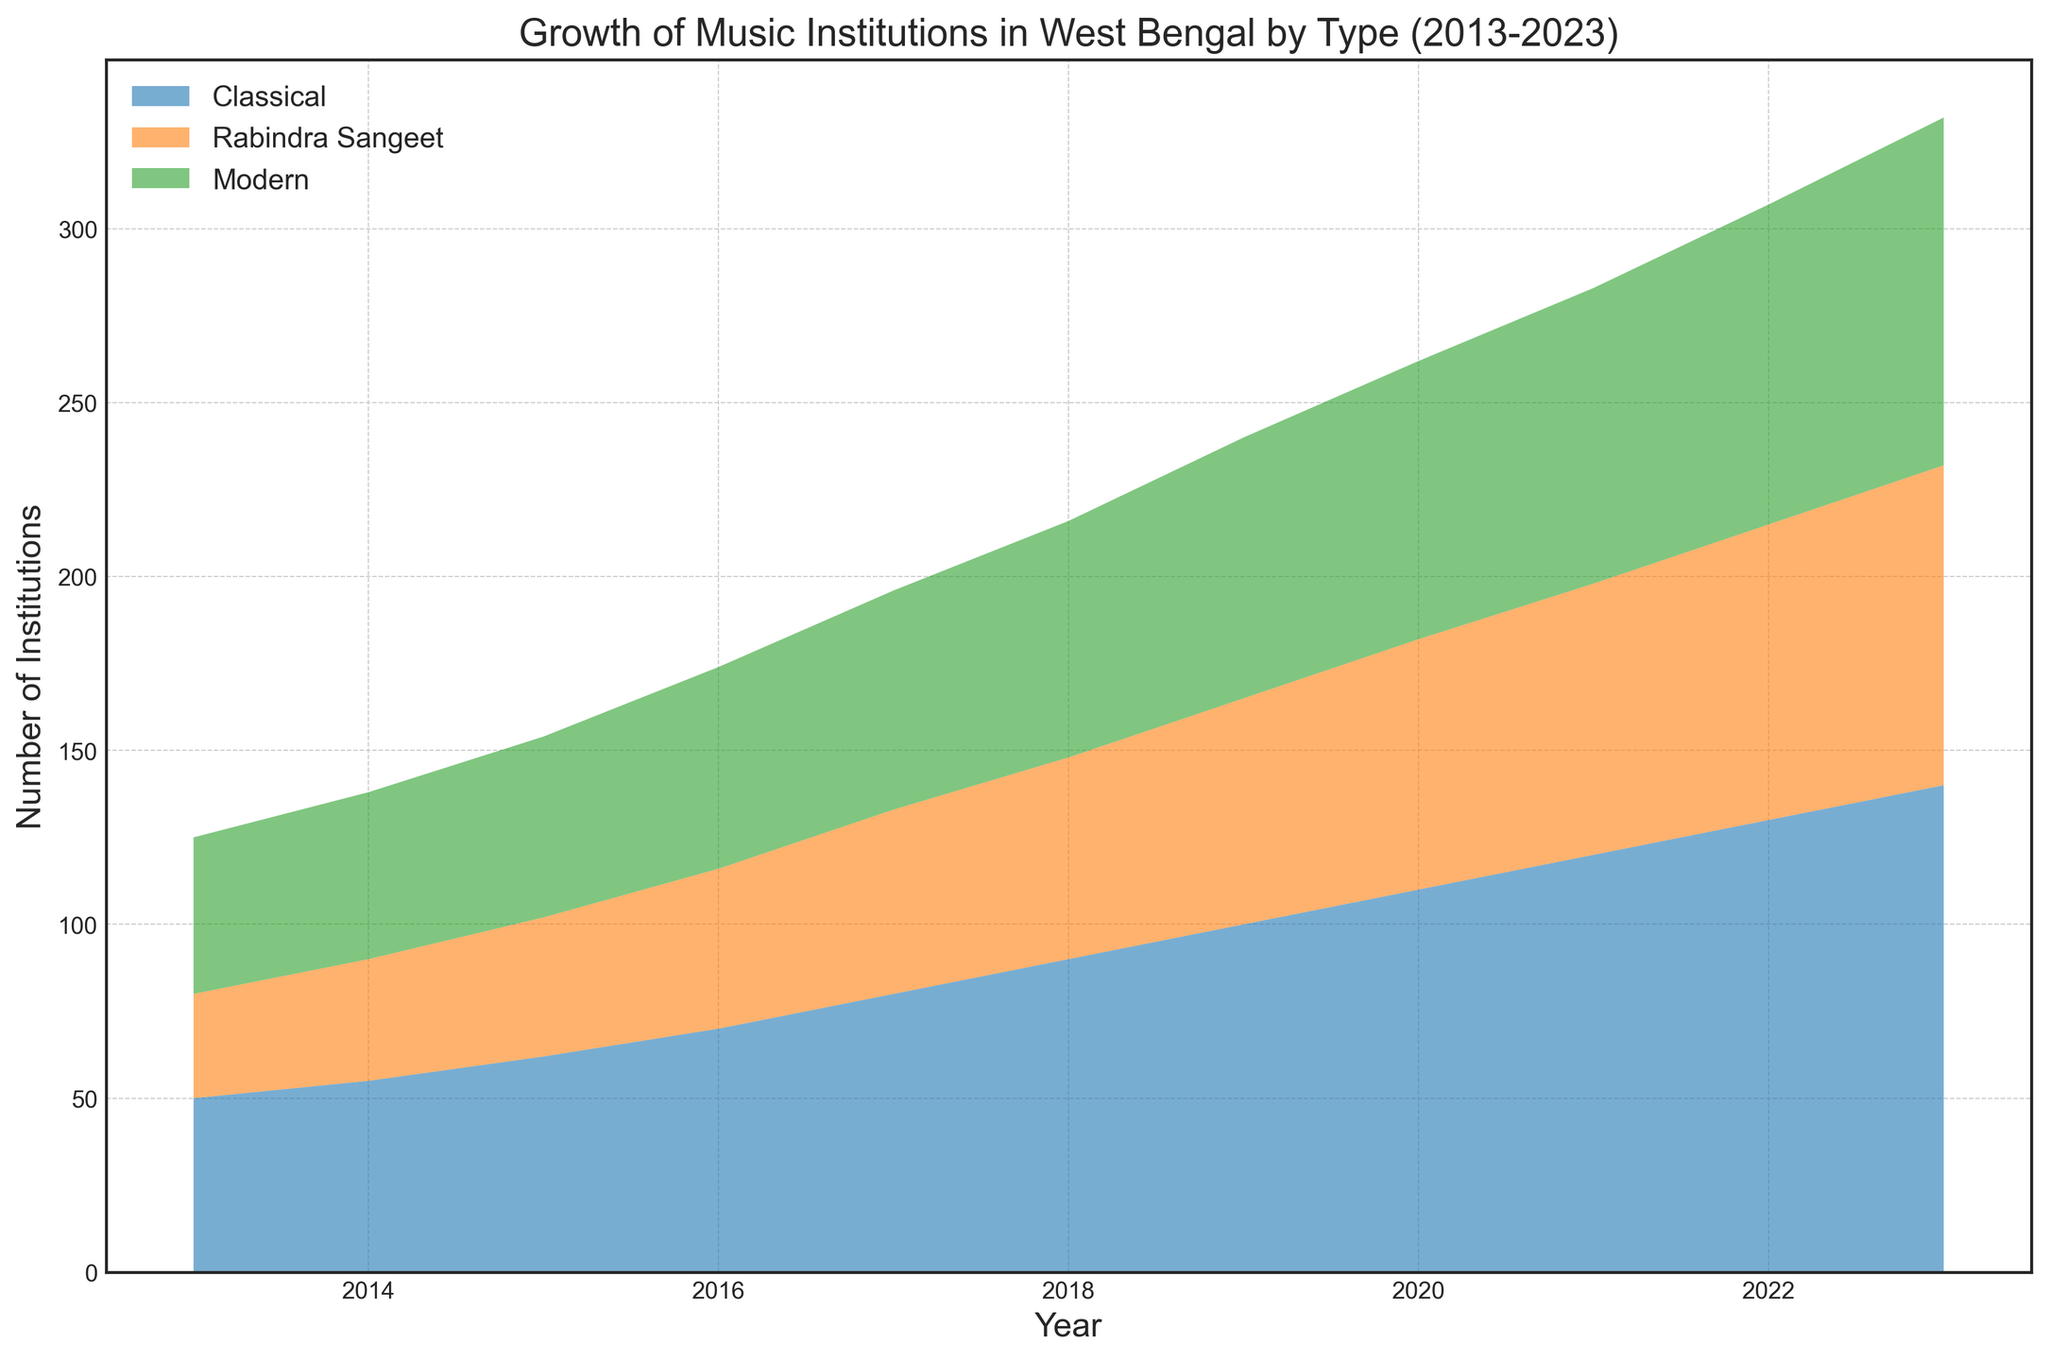What type of music institution saw the biggest increase in the number of institutions from 2013 to 2023? To determine the type of music institution with the greatest increase, find the difference between the number of institutions in 2023 and 2013 for each type. Classical increased from 50 to 140 (90), Rabindra Sangeet from 30 to 92 (62), and Modern from 45 to 100 (55). Thus, Classical saw the biggest increase.
Answer: Classical Which type of music institution had the most institutions in 2020? Examine the value for each type of music institution in 2020. Classical had 110, Rabindra Sangeet had 72, and Modern had 80. So, Classical had the most institutions in 2020.
Answer: Classical By how many institutions did Modern music institutions surpass Rabindra Sangeet institutions in 2023? Compare the values for Modern and Rabindra Sangeet in 2023. Modern had 100 institutions and Rabindra Sangeet had 92. The difference is 100 - 92 = 8.
Answer: 8 What is the average number of Rabindra Sangeet institutions from 2013 to 2023? Sum the number of Rabindra Sangeet institutions over the years (30 + 35 + 40 + 46 + 53 + 58 + 65 + 72 + 78 + 85 + 92) = 654. There are 11 years, so the average is 654/11 ≈ 59.45.
Answer: 59.45 Which year did the number of Classical institutions first exceed 100? Look for the first year where the number of Classical institutions exceeds 100. In 2019, there were 100 institutions, and in 2020, there were 110. Therefore, the year is 2020.
Answer: 2020 In which period did Rabindra Sangeet music institutions see the largest increase? Calculate the yearly increase for Rabindra Sangeet and identify the largest. Between 2019 to 2020, there is a 7 institution increase (72 - 65). Identify the largest single-year increase: there are consistent increases but 7 is the largest.
Answer: 2019-2020 What is the total number of music institutions in 2023 across all categories? Sum the number of institutions in each category for 2023: Classical (140), Rabindra Sangeet (92), and Modern (100). Total is 140 + 92 + 100 = 332.
Answer: 332 How many more Classical institutions were there compared to Modern institutions in 2017? In 2017, there were 80 Classical institutions and 63 Modern institutions. The difference is 80 - 63 = 17.
Answer: 17 Which music institution category experienced the smallest growth from 2013 to 2023? Calculate the growth for each category from 2013 to 2023: Classical (140 - 50 = 90), Rabindra Sangeet (92 - 30 = 62), Modern (100 - 45 = 55). Modern has the smallest growth.
Answer: Modern What was the combined number of Classical and Rabindra Sangeet institutions in 2015? Sum the number of institutions in the Classical (62) and Rabindra Sangeet (40) categories for 2015. Combined total is 62 + 40 = 102.
Answer: 102 